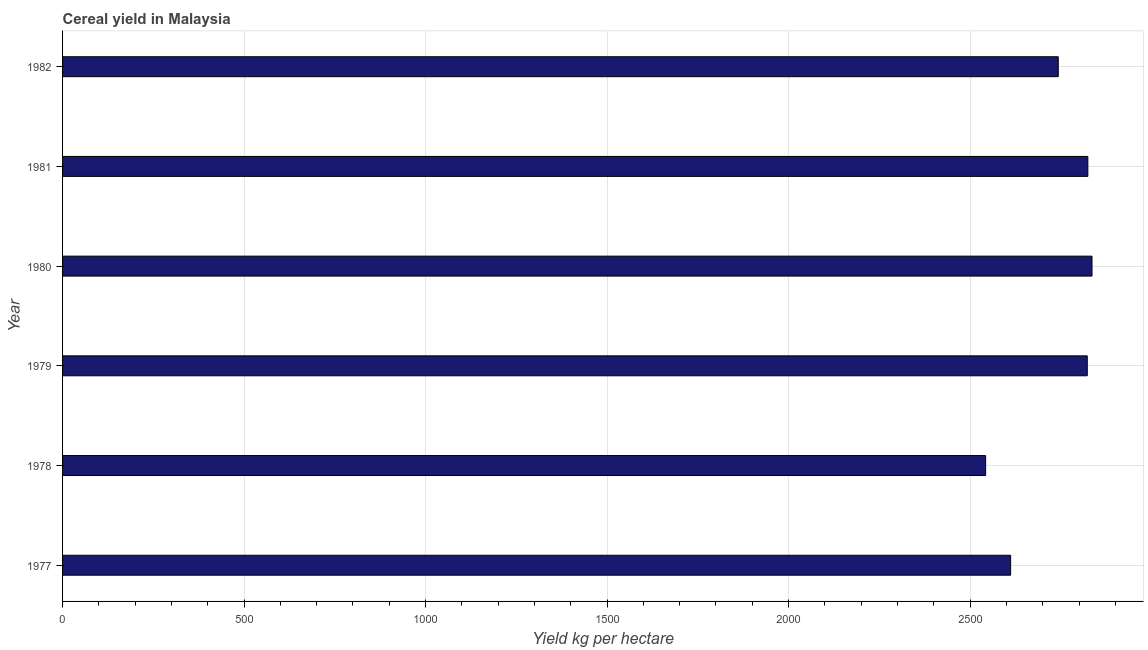Does the graph contain grids?
Give a very brief answer. Yes. What is the title of the graph?
Your response must be concise. Cereal yield in Malaysia. What is the label or title of the X-axis?
Provide a succinct answer. Yield kg per hectare. What is the cereal yield in 1979?
Your answer should be compact. 2822.82. Across all years, what is the maximum cereal yield?
Your answer should be compact. 2835.87. Across all years, what is the minimum cereal yield?
Make the answer very short. 2542.78. In which year was the cereal yield minimum?
Provide a succinct answer. 1978. What is the sum of the cereal yield?
Ensure brevity in your answer.  1.64e+04. What is the difference between the cereal yield in 1977 and 1981?
Keep it short and to the point. -212.68. What is the average cereal yield per year?
Ensure brevity in your answer.  2730.07. What is the median cereal yield?
Provide a short and direct response. 2782.86. What is the difference between the highest and the second highest cereal yield?
Make the answer very short. 11.5. What is the difference between the highest and the lowest cereal yield?
Give a very brief answer. 293.1. In how many years, is the cereal yield greater than the average cereal yield taken over all years?
Ensure brevity in your answer.  4. Are all the bars in the graph horizontal?
Provide a succinct answer. Yes. How many years are there in the graph?
Give a very brief answer. 6. What is the difference between two consecutive major ticks on the X-axis?
Give a very brief answer. 500. What is the Yield kg per hectare of 1977?
Make the answer very short. 2611.69. What is the Yield kg per hectare in 1978?
Your answer should be compact. 2542.78. What is the Yield kg per hectare in 1979?
Make the answer very short. 2822.82. What is the Yield kg per hectare of 1980?
Provide a succinct answer. 2835.87. What is the Yield kg per hectare of 1981?
Your response must be concise. 2824.37. What is the Yield kg per hectare in 1982?
Give a very brief answer. 2742.9. What is the difference between the Yield kg per hectare in 1977 and 1978?
Your answer should be very brief. 68.91. What is the difference between the Yield kg per hectare in 1977 and 1979?
Your response must be concise. -211.13. What is the difference between the Yield kg per hectare in 1977 and 1980?
Provide a succinct answer. -224.18. What is the difference between the Yield kg per hectare in 1977 and 1981?
Provide a short and direct response. -212.68. What is the difference between the Yield kg per hectare in 1977 and 1982?
Your response must be concise. -131.22. What is the difference between the Yield kg per hectare in 1978 and 1979?
Provide a short and direct response. -280.04. What is the difference between the Yield kg per hectare in 1978 and 1980?
Provide a short and direct response. -293.1. What is the difference between the Yield kg per hectare in 1978 and 1981?
Provide a succinct answer. -281.6. What is the difference between the Yield kg per hectare in 1978 and 1982?
Give a very brief answer. -200.13. What is the difference between the Yield kg per hectare in 1979 and 1980?
Your response must be concise. -13.05. What is the difference between the Yield kg per hectare in 1979 and 1981?
Keep it short and to the point. -1.55. What is the difference between the Yield kg per hectare in 1979 and 1982?
Your answer should be compact. 79.92. What is the difference between the Yield kg per hectare in 1980 and 1981?
Keep it short and to the point. 11.5. What is the difference between the Yield kg per hectare in 1980 and 1982?
Keep it short and to the point. 92.97. What is the difference between the Yield kg per hectare in 1981 and 1982?
Your response must be concise. 81.47. What is the ratio of the Yield kg per hectare in 1977 to that in 1978?
Provide a succinct answer. 1.03. What is the ratio of the Yield kg per hectare in 1977 to that in 1979?
Offer a terse response. 0.93. What is the ratio of the Yield kg per hectare in 1977 to that in 1980?
Ensure brevity in your answer.  0.92. What is the ratio of the Yield kg per hectare in 1977 to that in 1981?
Keep it short and to the point. 0.93. What is the ratio of the Yield kg per hectare in 1978 to that in 1979?
Your answer should be compact. 0.9. What is the ratio of the Yield kg per hectare in 1978 to that in 1980?
Make the answer very short. 0.9. What is the ratio of the Yield kg per hectare in 1978 to that in 1982?
Your answer should be compact. 0.93. What is the ratio of the Yield kg per hectare in 1979 to that in 1980?
Offer a terse response. 0.99. What is the ratio of the Yield kg per hectare in 1979 to that in 1981?
Your answer should be compact. 1. What is the ratio of the Yield kg per hectare in 1980 to that in 1982?
Your answer should be compact. 1.03. 